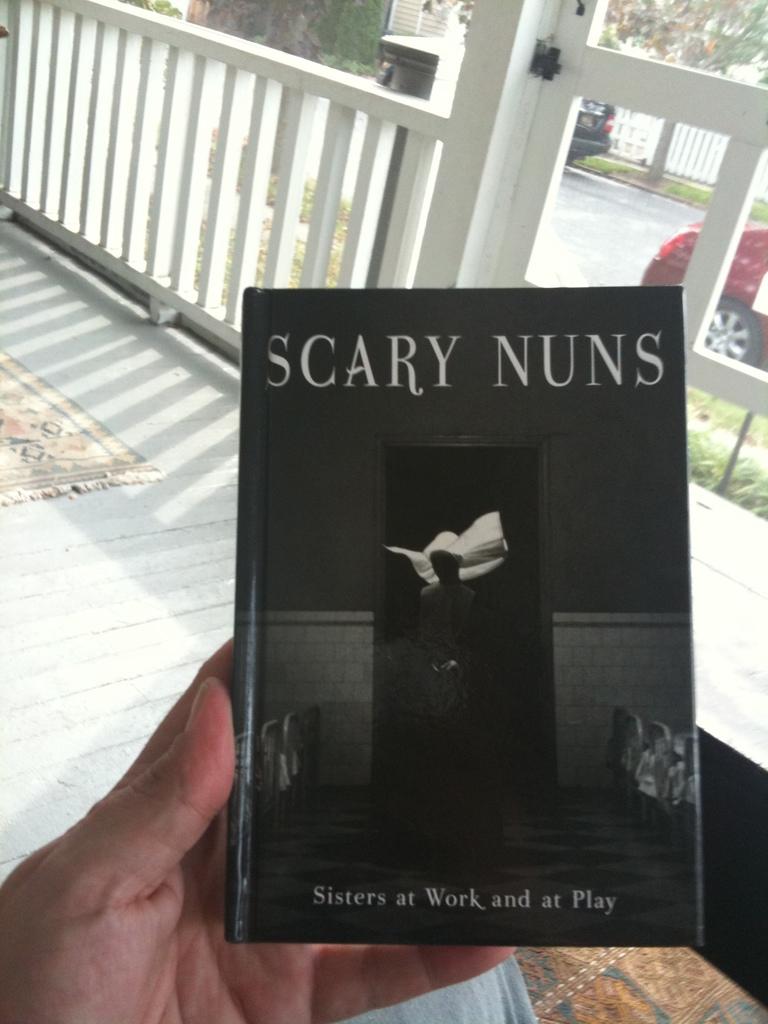What is the text at the bottom of the book?
Provide a succinct answer. Sisters at work and at play. 